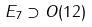<formula> <loc_0><loc_0><loc_500><loc_500>E _ { 7 } \supset O ( 1 2 )</formula> 